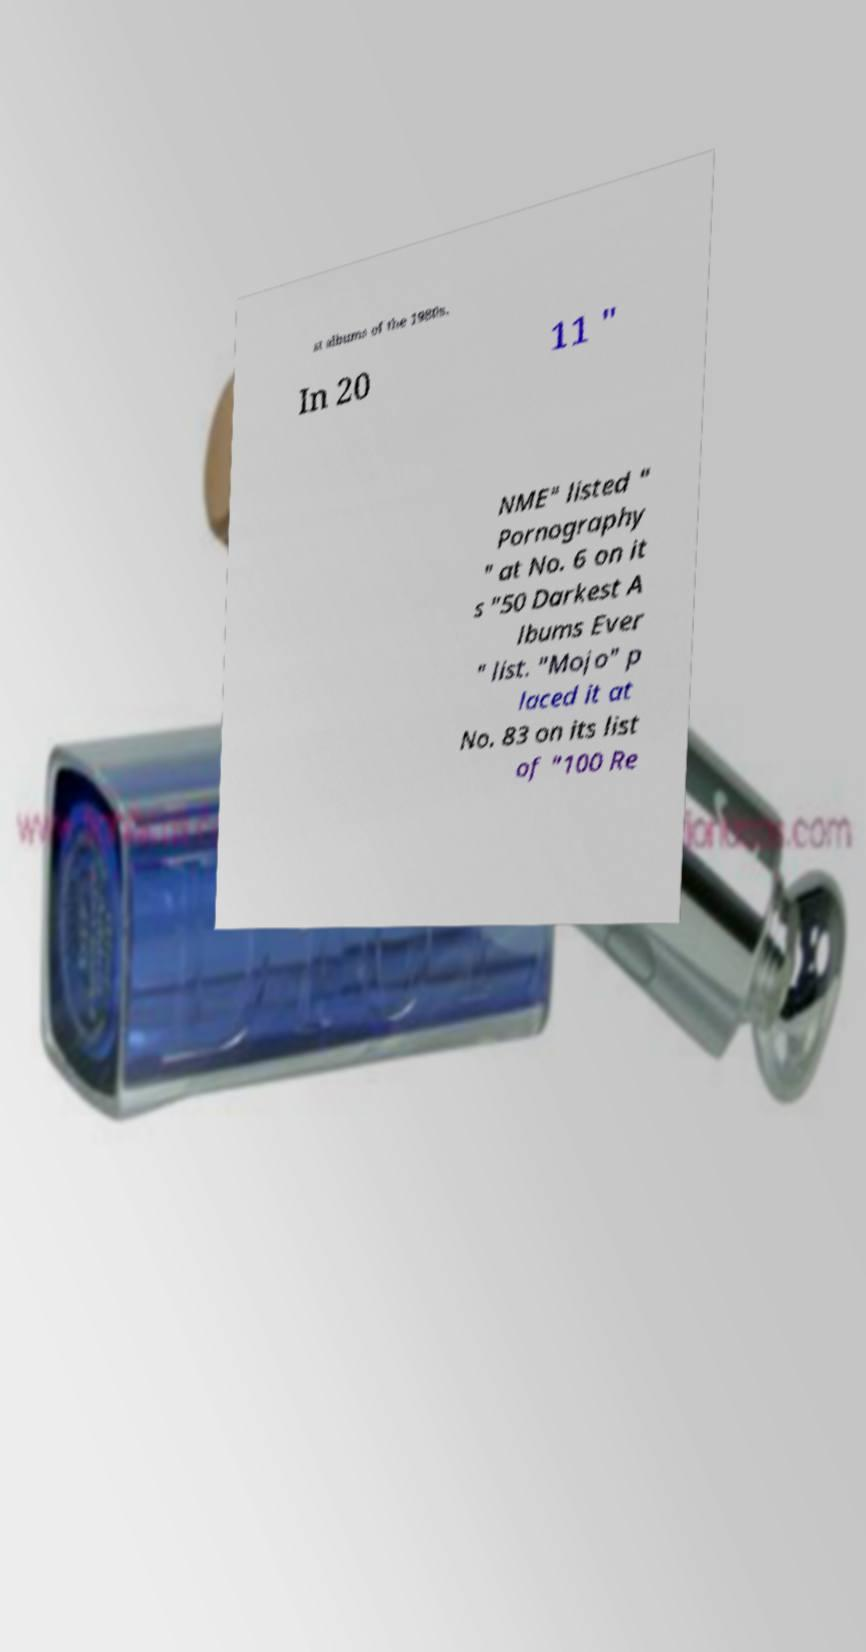Can you accurately transcribe the text from the provided image for me? st albums of the 1980s. In 20 11 " NME" listed " Pornography " at No. 6 on it s "50 Darkest A lbums Ever " list. "Mojo" p laced it at No. 83 on its list of "100 Re 